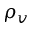<formula> <loc_0><loc_0><loc_500><loc_500>\rho _ { v }</formula> 